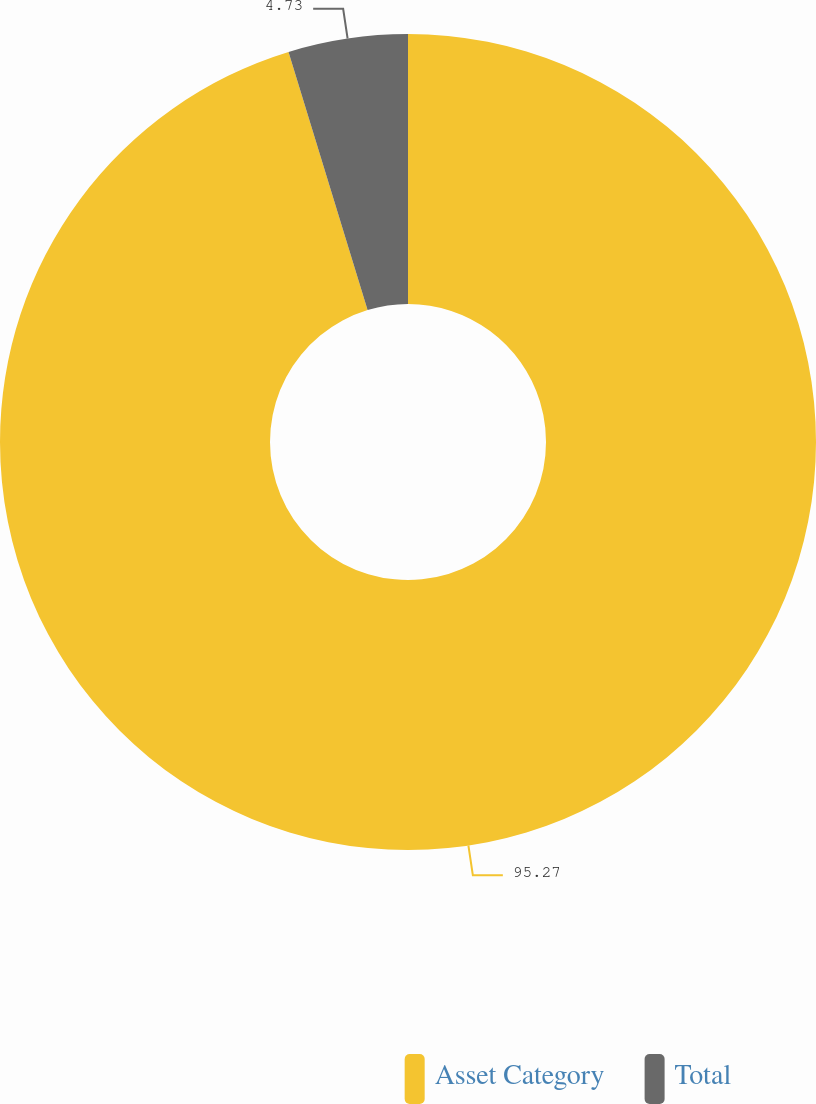Convert chart to OTSL. <chart><loc_0><loc_0><loc_500><loc_500><pie_chart><fcel>Asset Category<fcel>Total<nl><fcel>95.27%<fcel>4.73%<nl></chart> 